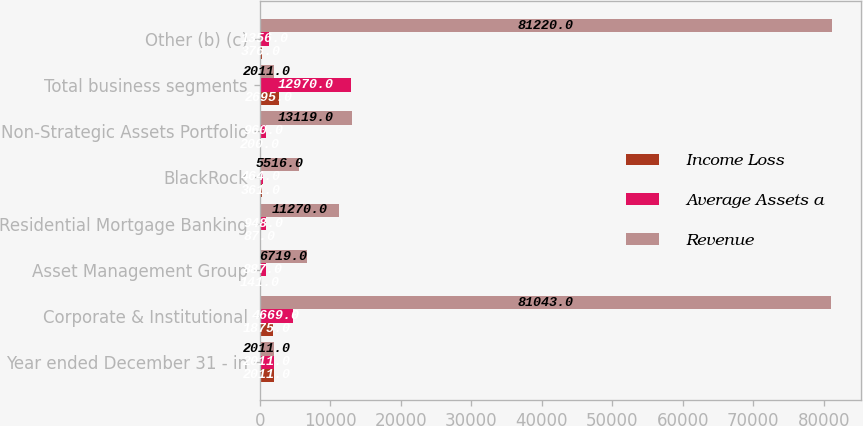Convert chart. <chart><loc_0><loc_0><loc_500><loc_500><stacked_bar_chart><ecel><fcel>Year ended December 31 - in<fcel>Corporate & Institutional<fcel>Asset Management Group<fcel>Residential Mortgage Banking<fcel>BlackRock<fcel>Non-Strategic Assets Portfolio<fcel>Total business segments<fcel>Other (b) (c)<nl><fcel>Income Loss<fcel>2011<fcel>1875<fcel>141<fcel>87<fcel>361<fcel>200<fcel>2695<fcel>376<nl><fcel>Average Assets a<fcel>2011<fcel>4669<fcel>887<fcel>948<fcel>464<fcel>960<fcel>12970<fcel>1356<nl><fcel>Revenue<fcel>2011<fcel>81043<fcel>6719<fcel>11270<fcel>5516<fcel>13119<fcel>2011<fcel>81220<nl></chart> 